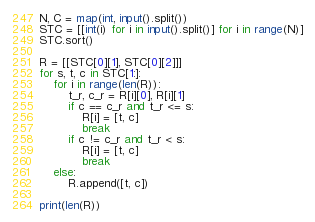<code> <loc_0><loc_0><loc_500><loc_500><_Python_>N, C = map(int, input().split())
STC = [[int(i) for i in input().split()] for i in range(N)]
STC.sort()

R = [[STC[0][1], STC[0][2]]]
for s, t, c in STC[1:]:
    for i in range(len(R)):
        t_r, c_r = R[i][0], R[i][1]
        if c == c_r and t_r <= s:
            R[i] = [t, c]
            break
        if c != c_r and t_r < s:
            R[i] = [t, c]
            break
    else:
        R.append([t, c])
        
print(len(R))</code> 